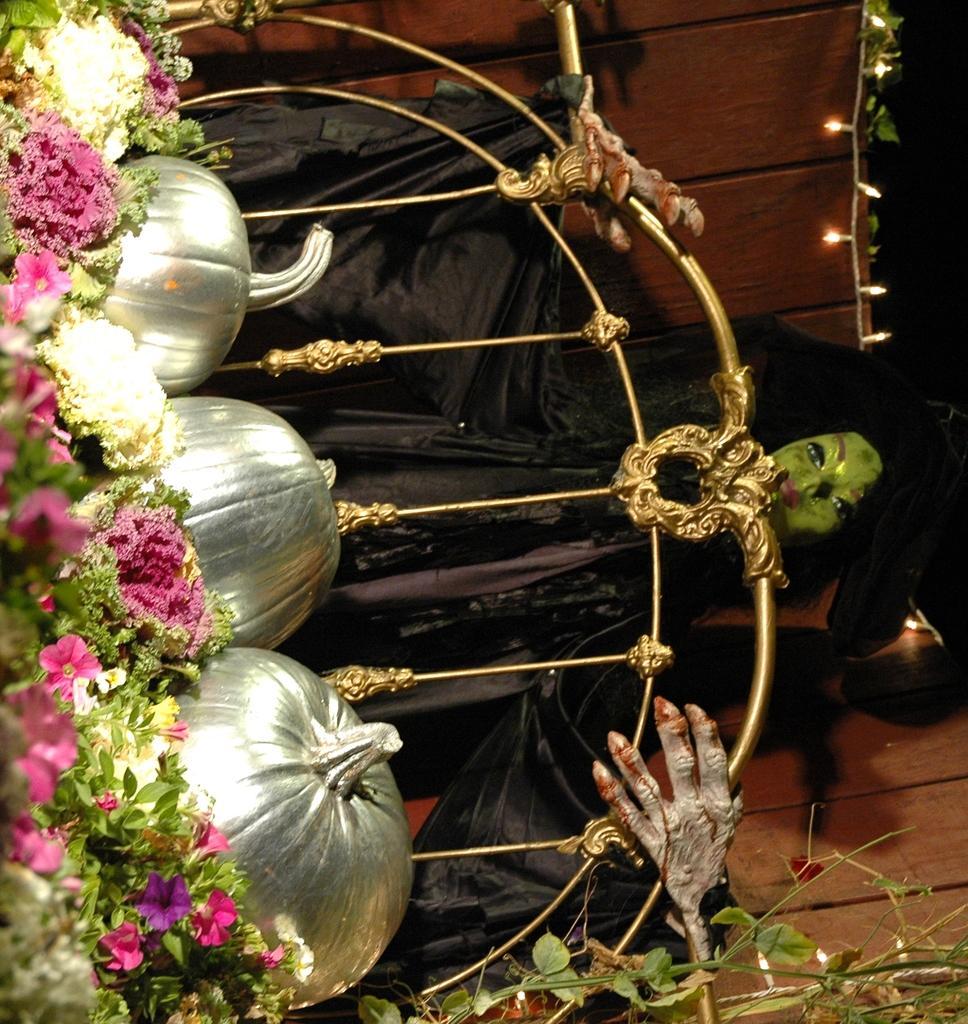Could you give a brief overview of what you see in this image? In this image there are pumpkins, rods, statue, decorative lights, flower plants, leaves, wooden wall and objects.   